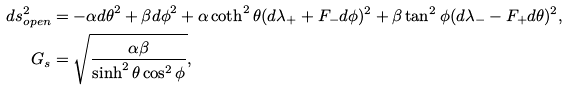Convert formula to latex. <formula><loc_0><loc_0><loc_500><loc_500>d s ^ { 2 } _ { o p e n } & = - \alpha { d \theta } ^ { 2 } + \beta { d \phi } ^ { 2 } + \alpha \coth ^ { 2 } \theta ( d \lambda _ { + } + F _ { - } d { \phi } ) ^ { 2 } + \beta \tan ^ { 2 } { \phi } ( d \lambda _ { - } - F _ { + } d \theta ) ^ { 2 } , \\ G _ { s } & = \sqrt { \frac { \alpha \beta } { \sinh ^ { 2 } \theta \cos ^ { 2 } { \phi } } } ,</formula> 